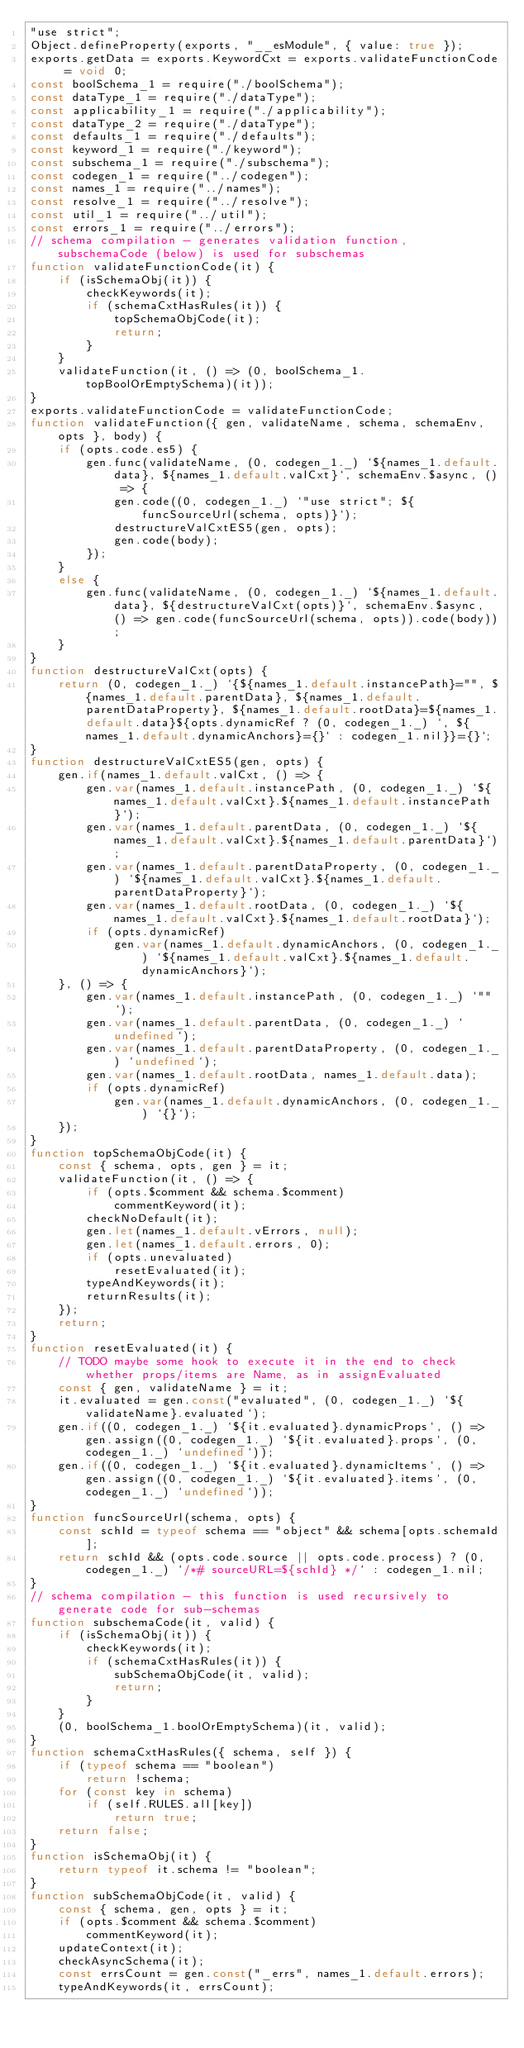<code> <loc_0><loc_0><loc_500><loc_500><_JavaScript_>"use strict";
Object.defineProperty(exports, "__esModule", { value: true });
exports.getData = exports.KeywordCxt = exports.validateFunctionCode = void 0;
const boolSchema_1 = require("./boolSchema");
const dataType_1 = require("./dataType");
const applicability_1 = require("./applicability");
const dataType_2 = require("./dataType");
const defaults_1 = require("./defaults");
const keyword_1 = require("./keyword");
const subschema_1 = require("./subschema");
const codegen_1 = require("../codegen");
const names_1 = require("../names");
const resolve_1 = require("../resolve");
const util_1 = require("../util");
const errors_1 = require("../errors");
// schema compilation - generates validation function, subschemaCode (below) is used for subschemas
function validateFunctionCode(it) {
    if (isSchemaObj(it)) {
        checkKeywords(it);
        if (schemaCxtHasRules(it)) {
            topSchemaObjCode(it);
            return;
        }
    }
    validateFunction(it, () => (0, boolSchema_1.topBoolOrEmptySchema)(it));
}
exports.validateFunctionCode = validateFunctionCode;
function validateFunction({ gen, validateName, schema, schemaEnv, opts }, body) {
    if (opts.code.es5) {
        gen.func(validateName, (0, codegen_1._) `${names_1.default.data}, ${names_1.default.valCxt}`, schemaEnv.$async, () => {
            gen.code((0, codegen_1._) `"use strict"; ${funcSourceUrl(schema, opts)}`);
            destructureValCxtES5(gen, opts);
            gen.code(body);
        });
    }
    else {
        gen.func(validateName, (0, codegen_1._) `${names_1.default.data}, ${destructureValCxt(opts)}`, schemaEnv.$async, () => gen.code(funcSourceUrl(schema, opts)).code(body));
    }
}
function destructureValCxt(opts) {
    return (0, codegen_1._) `{${names_1.default.instancePath}="", ${names_1.default.parentData}, ${names_1.default.parentDataProperty}, ${names_1.default.rootData}=${names_1.default.data}${opts.dynamicRef ? (0, codegen_1._) `, ${names_1.default.dynamicAnchors}={}` : codegen_1.nil}}={}`;
}
function destructureValCxtES5(gen, opts) {
    gen.if(names_1.default.valCxt, () => {
        gen.var(names_1.default.instancePath, (0, codegen_1._) `${names_1.default.valCxt}.${names_1.default.instancePath}`);
        gen.var(names_1.default.parentData, (0, codegen_1._) `${names_1.default.valCxt}.${names_1.default.parentData}`);
        gen.var(names_1.default.parentDataProperty, (0, codegen_1._) `${names_1.default.valCxt}.${names_1.default.parentDataProperty}`);
        gen.var(names_1.default.rootData, (0, codegen_1._) `${names_1.default.valCxt}.${names_1.default.rootData}`);
        if (opts.dynamicRef)
            gen.var(names_1.default.dynamicAnchors, (0, codegen_1._) `${names_1.default.valCxt}.${names_1.default.dynamicAnchors}`);
    }, () => {
        gen.var(names_1.default.instancePath, (0, codegen_1._) `""`);
        gen.var(names_1.default.parentData, (0, codegen_1._) `undefined`);
        gen.var(names_1.default.parentDataProperty, (0, codegen_1._) `undefined`);
        gen.var(names_1.default.rootData, names_1.default.data);
        if (opts.dynamicRef)
            gen.var(names_1.default.dynamicAnchors, (0, codegen_1._) `{}`);
    });
}
function topSchemaObjCode(it) {
    const { schema, opts, gen } = it;
    validateFunction(it, () => {
        if (opts.$comment && schema.$comment)
            commentKeyword(it);
        checkNoDefault(it);
        gen.let(names_1.default.vErrors, null);
        gen.let(names_1.default.errors, 0);
        if (opts.unevaluated)
            resetEvaluated(it);
        typeAndKeywords(it);
        returnResults(it);
    });
    return;
}
function resetEvaluated(it) {
    // TODO maybe some hook to execute it in the end to check whether props/items are Name, as in assignEvaluated
    const { gen, validateName } = it;
    it.evaluated = gen.const("evaluated", (0, codegen_1._) `${validateName}.evaluated`);
    gen.if((0, codegen_1._) `${it.evaluated}.dynamicProps`, () => gen.assign((0, codegen_1._) `${it.evaluated}.props`, (0, codegen_1._) `undefined`));
    gen.if((0, codegen_1._) `${it.evaluated}.dynamicItems`, () => gen.assign((0, codegen_1._) `${it.evaluated}.items`, (0, codegen_1._) `undefined`));
}
function funcSourceUrl(schema, opts) {
    const schId = typeof schema == "object" && schema[opts.schemaId];
    return schId && (opts.code.source || opts.code.process) ? (0, codegen_1._) `/*# sourceURL=${schId} */` : codegen_1.nil;
}
// schema compilation - this function is used recursively to generate code for sub-schemas
function subschemaCode(it, valid) {
    if (isSchemaObj(it)) {
        checkKeywords(it);
        if (schemaCxtHasRules(it)) {
            subSchemaObjCode(it, valid);
            return;
        }
    }
    (0, boolSchema_1.boolOrEmptySchema)(it, valid);
}
function schemaCxtHasRules({ schema, self }) {
    if (typeof schema == "boolean")
        return !schema;
    for (const key in schema)
        if (self.RULES.all[key])
            return true;
    return false;
}
function isSchemaObj(it) {
    return typeof it.schema != "boolean";
}
function subSchemaObjCode(it, valid) {
    const { schema, gen, opts } = it;
    if (opts.$comment && schema.$comment)
        commentKeyword(it);
    updateContext(it);
    checkAsyncSchema(it);
    const errsCount = gen.const("_errs", names_1.default.errors);
    typeAndKeywords(it, errsCount);</code> 